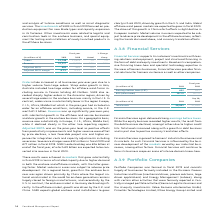According to Siemens Ag's financial document, What caused the Total assets to increase? Total assets increased along with a growth in debt business and in part due to positive currency translation effects.. The document states: "eclined, amongst others due to higher credit hits. Total assets increased along with a growth in debt business and in part due to positive currency tr..." Also, How did the equity and debt businesses reacted to the credit hits? While the equity business recorded higher results, the result from the debt business declined, amongst others due to higher credit hits. Total assets increased along with a growth in debt business and in part due to positive currency translation effects.. The document states: "ces again delivered strong earnings before taxes . While the equity business recorded higher results, the result from the debt business declined, amon..." Also, What is the scope of Financial services business? Financial Services will continue to focus its business scope on areas of intense domain know-how.. The document states: "our industrial busi- nesses, among other factors. Financial Services will continue to focus its business scope on areas of intense domain know-how...." Also, can you calculate: What is the increase / (decrease) in the Earnings before taxes from 2018 to 2019? Based on the calculation: 632 - 633, the result is -1 (in millions). This is based on the information: "Earnings before taxes (EBT) 632 633 Earnings before taxes (EBT) 632 633..." The key data points involved are: 632, 633. Also, can you calculate: What is the average total assets in 2018 and 2019? To answer this question, I need to perform calculations using the financial data. The calculation is: (29,901 + 27,628) / 2, which equals 28764.5 (in millions). This is based on the information: "Total assets 29,901 27,628 Total assets 29,901 27,628..." The key data points involved are: 27,628, 29,901. Also, can you calculate: What is the increase / (decrease) in the ROE(after taxes) from 2018 to 2019? Based on the calculation: 19.1% - 19.7%, the result is -0.6 (percentage). This is based on the information: "ROE (after taxes) 19.1 % 19.7 % ROE (after taxes) 19.1 % 19.7 %..." The key data points involved are: 19.1, 19.7. 